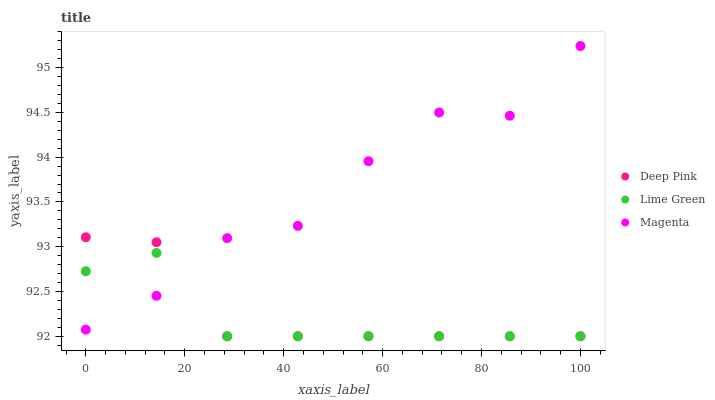Does Lime Green have the minimum area under the curve?
Answer yes or no. Yes. Does Magenta have the maximum area under the curve?
Answer yes or no. Yes. Does Deep Pink have the minimum area under the curve?
Answer yes or no. No. Does Deep Pink have the maximum area under the curve?
Answer yes or no. No. Is Deep Pink the smoothest?
Answer yes or no. Yes. Is Magenta the roughest?
Answer yes or no. Yes. Is Lime Green the smoothest?
Answer yes or no. No. Is Lime Green the roughest?
Answer yes or no. No. Does Deep Pink have the lowest value?
Answer yes or no. Yes. Does Magenta have the highest value?
Answer yes or no. Yes. Does Deep Pink have the highest value?
Answer yes or no. No. Does Lime Green intersect Magenta?
Answer yes or no. Yes. Is Lime Green less than Magenta?
Answer yes or no. No. Is Lime Green greater than Magenta?
Answer yes or no. No. 